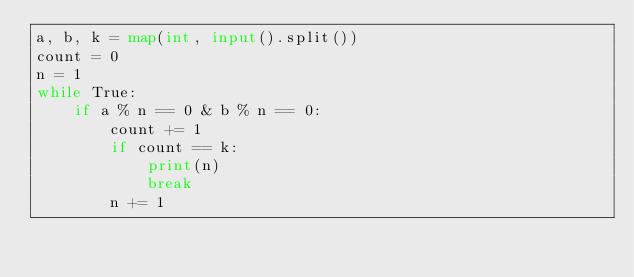Convert code to text. <code><loc_0><loc_0><loc_500><loc_500><_Python_>a, b, k = map(int, input().split())
count = 0
n = 1
while True:
    if a % n == 0 & b % n == 0:
        count += 1
        if count == k:
            print(n)
            break
        n += 1
</code> 